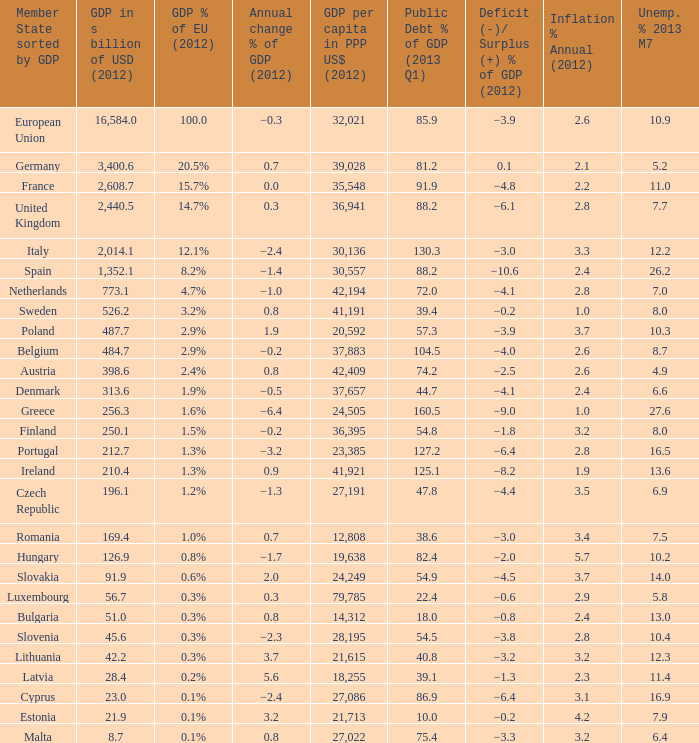What is the shortfall/excess % of the 2012 gdp of the nation with a gdp in billions of usd in 2012 below 1,35 −0.6. 